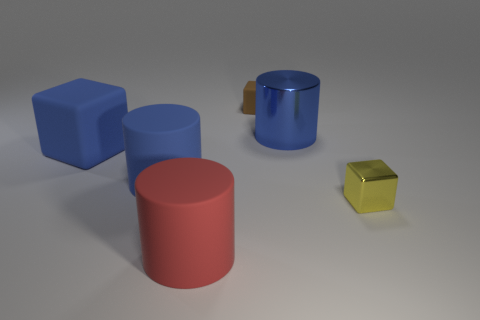Subtract all matte cylinders. How many cylinders are left? 1 Subtract all yellow balls. How many blue cylinders are left? 2 Subtract 1 blocks. How many blocks are left? 2 Add 3 large blue metal objects. How many objects exist? 9 Subtract all gray cubes. Subtract all purple cylinders. How many cubes are left? 3 Subtract 0 yellow cylinders. How many objects are left? 6 Subtract all blue cylinders. Subtract all blue metal objects. How many objects are left? 3 Add 3 tiny yellow things. How many tiny yellow things are left? 4 Add 3 cyan metal objects. How many cyan metal objects exist? 3 